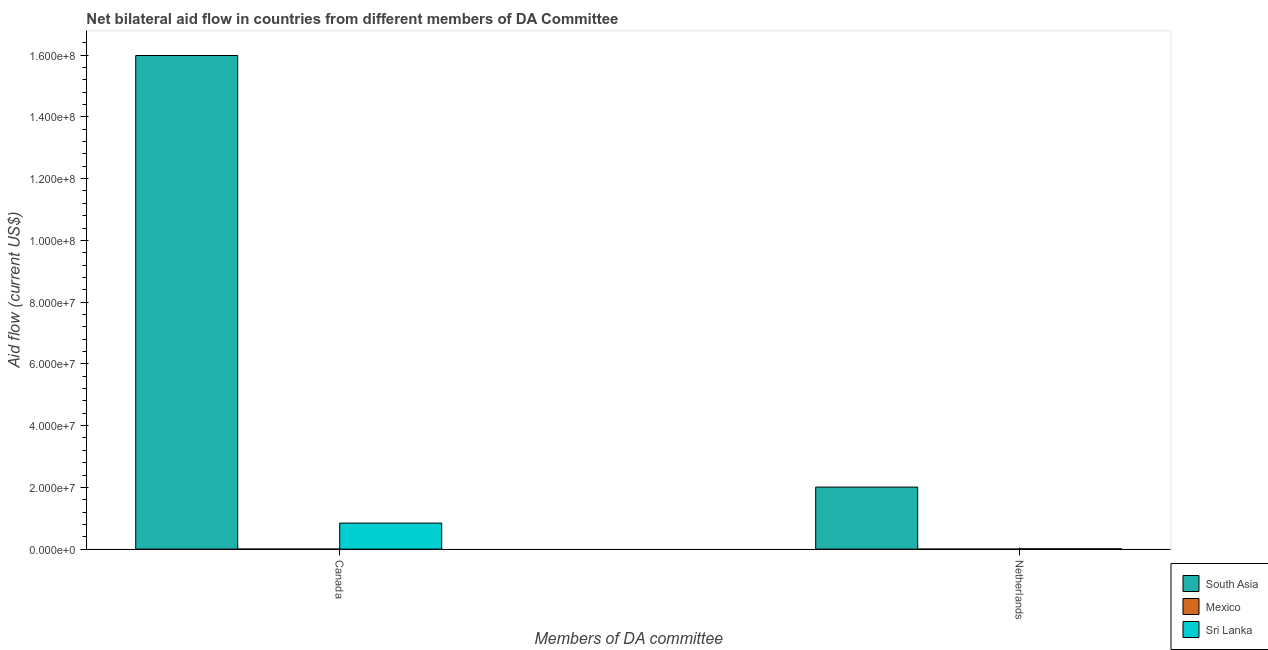How many groups of bars are there?
Provide a short and direct response. 2. Are the number of bars per tick equal to the number of legend labels?
Your answer should be compact. Yes. Are the number of bars on each tick of the X-axis equal?
Your response must be concise. Yes. What is the label of the 2nd group of bars from the left?
Your response must be concise. Netherlands. What is the amount of aid given by netherlands in Mexico?
Provide a short and direct response. 10000. Across all countries, what is the maximum amount of aid given by canada?
Your response must be concise. 1.60e+08. Across all countries, what is the minimum amount of aid given by netherlands?
Offer a terse response. 10000. In which country was the amount of aid given by canada maximum?
Make the answer very short. South Asia. In which country was the amount of aid given by netherlands minimum?
Give a very brief answer. Mexico. What is the total amount of aid given by netherlands in the graph?
Offer a terse response. 2.02e+07. What is the difference between the amount of aid given by netherlands in South Asia and that in Sri Lanka?
Make the answer very short. 2.00e+07. What is the difference between the amount of aid given by netherlands in South Asia and the amount of aid given by canada in Mexico?
Provide a short and direct response. 2.01e+07. What is the average amount of aid given by netherlands per country?
Ensure brevity in your answer.  6.74e+06. What is the difference between the amount of aid given by netherlands and amount of aid given by canada in Sri Lanka?
Make the answer very short. -8.33e+06. In how many countries, is the amount of aid given by netherlands greater than 132000000 US$?
Provide a succinct answer. 0. What is the ratio of the amount of aid given by canada in Sri Lanka to that in Mexico?
Make the answer very short. 422. Is the amount of aid given by canada in Mexico less than that in Sri Lanka?
Your answer should be very brief. Yes. In how many countries, is the amount of aid given by netherlands greater than the average amount of aid given by netherlands taken over all countries?
Your response must be concise. 1. What does the 3rd bar from the right in Netherlands represents?
Give a very brief answer. South Asia. Are all the bars in the graph horizontal?
Give a very brief answer. No. How many countries are there in the graph?
Provide a succinct answer. 3. Are the values on the major ticks of Y-axis written in scientific E-notation?
Your answer should be very brief. Yes. Does the graph contain grids?
Ensure brevity in your answer.  No. How are the legend labels stacked?
Offer a very short reply. Vertical. What is the title of the graph?
Your answer should be very brief. Net bilateral aid flow in countries from different members of DA Committee. What is the label or title of the X-axis?
Provide a succinct answer. Members of DA committee. What is the Aid flow (current US$) of South Asia in Canada?
Ensure brevity in your answer.  1.60e+08. What is the Aid flow (current US$) in Sri Lanka in Canada?
Make the answer very short. 8.44e+06. What is the Aid flow (current US$) of South Asia in Netherlands?
Make the answer very short. 2.01e+07. Across all Members of DA committee, what is the maximum Aid flow (current US$) in South Asia?
Keep it short and to the point. 1.60e+08. Across all Members of DA committee, what is the maximum Aid flow (current US$) in Mexico?
Provide a short and direct response. 2.00e+04. Across all Members of DA committee, what is the maximum Aid flow (current US$) in Sri Lanka?
Your answer should be very brief. 8.44e+06. Across all Members of DA committee, what is the minimum Aid flow (current US$) in South Asia?
Give a very brief answer. 2.01e+07. Across all Members of DA committee, what is the minimum Aid flow (current US$) of Mexico?
Offer a terse response. 10000. What is the total Aid flow (current US$) of South Asia in the graph?
Your answer should be very brief. 1.80e+08. What is the total Aid flow (current US$) of Mexico in the graph?
Your answer should be compact. 3.00e+04. What is the total Aid flow (current US$) of Sri Lanka in the graph?
Your response must be concise. 8.55e+06. What is the difference between the Aid flow (current US$) of South Asia in Canada and that in Netherlands?
Make the answer very short. 1.40e+08. What is the difference between the Aid flow (current US$) in Mexico in Canada and that in Netherlands?
Offer a very short reply. 10000. What is the difference between the Aid flow (current US$) of Sri Lanka in Canada and that in Netherlands?
Provide a succinct answer. 8.33e+06. What is the difference between the Aid flow (current US$) in South Asia in Canada and the Aid flow (current US$) in Mexico in Netherlands?
Make the answer very short. 1.60e+08. What is the difference between the Aid flow (current US$) of South Asia in Canada and the Aid flow (current US$) of Sri Lanka in Netherlands?
Your response must be concise. 1.60e+08. What is the difference between the Aid flow (current US$) of Mexico in Canada and the Aid flow (current US$) of Sri Lanka in Netherlands?
Provide a succinct answer. -9.00e+04. What is the average Aid flow (current US$) in South Asia per Members of DA committee?
Your answer should be compact. 9.00e+07. What is the average Aid flow (current US$) in Mexico per Members of DA committee?
Offer a terse response. 1.50e+04. What is the average Aid flow (current US$) in Sri Lanka per Members of DA committee?
Your response must be concise. 4.28e+06. What is the difference between the Aid flow (current US$) in South Asia and Aid flow (current US$) in Mexico in Canada?
Provide a short and direct response. 1.60e+08. What is the difference between the Aid flow (current US$) in South Asia and Aid flow (current US$) in Sri Lanka in Canada?
Provide a succinct answer. 1.51e+08. What is the difference between the Aid flow (current US$) of Mexico and Aid flow (current US$) of Sri Lanka in Canada?
Keep it short and to the point. -8.42e+06. What is the difference between the Aid flow (current US$) in South Asia and Aid flow (current US$) in Mexico in Netherlands?
Your response must be concise. 2.01e+07. What is the difference between the Aid flow (current US$) in South Asia and Aid flow (current US$) in Sri Lanka in Netherlands?
Make the answer very short. 2.00e+07. What is the ratio of the Aid flow (current US$) in South Asia in Canada to that in Netherlands?
Your answer should be compact. 7.95. What is the ratio of the Aid flow (current US$) of Sri Lanka in Canada to that in Netherlands?
Your answer should be very brief. 76.73. What is the difference between the highest and the second highest Aid flow (current US$) of South Asia?
Offer a terse response. 1.40e+08. What is the difference between the highest and the second highest Aid flow (current US$) of Mexico?
Provide a succinct answer. 10000. What is the difference between the highest and the second highest Aid flow (current US$) of Sri Lanka?
Ensure brevity in your answer.  8.33e+06. What is the difference between the highest and the lowest Aid flow (current US$) of South Asia?
Your answer should be compact. 1.40e+08. What is the difference between the highest and the lowest Aid flow (current US$) of Sri Lanka?
Your response must be concise. 8.33e+06. 